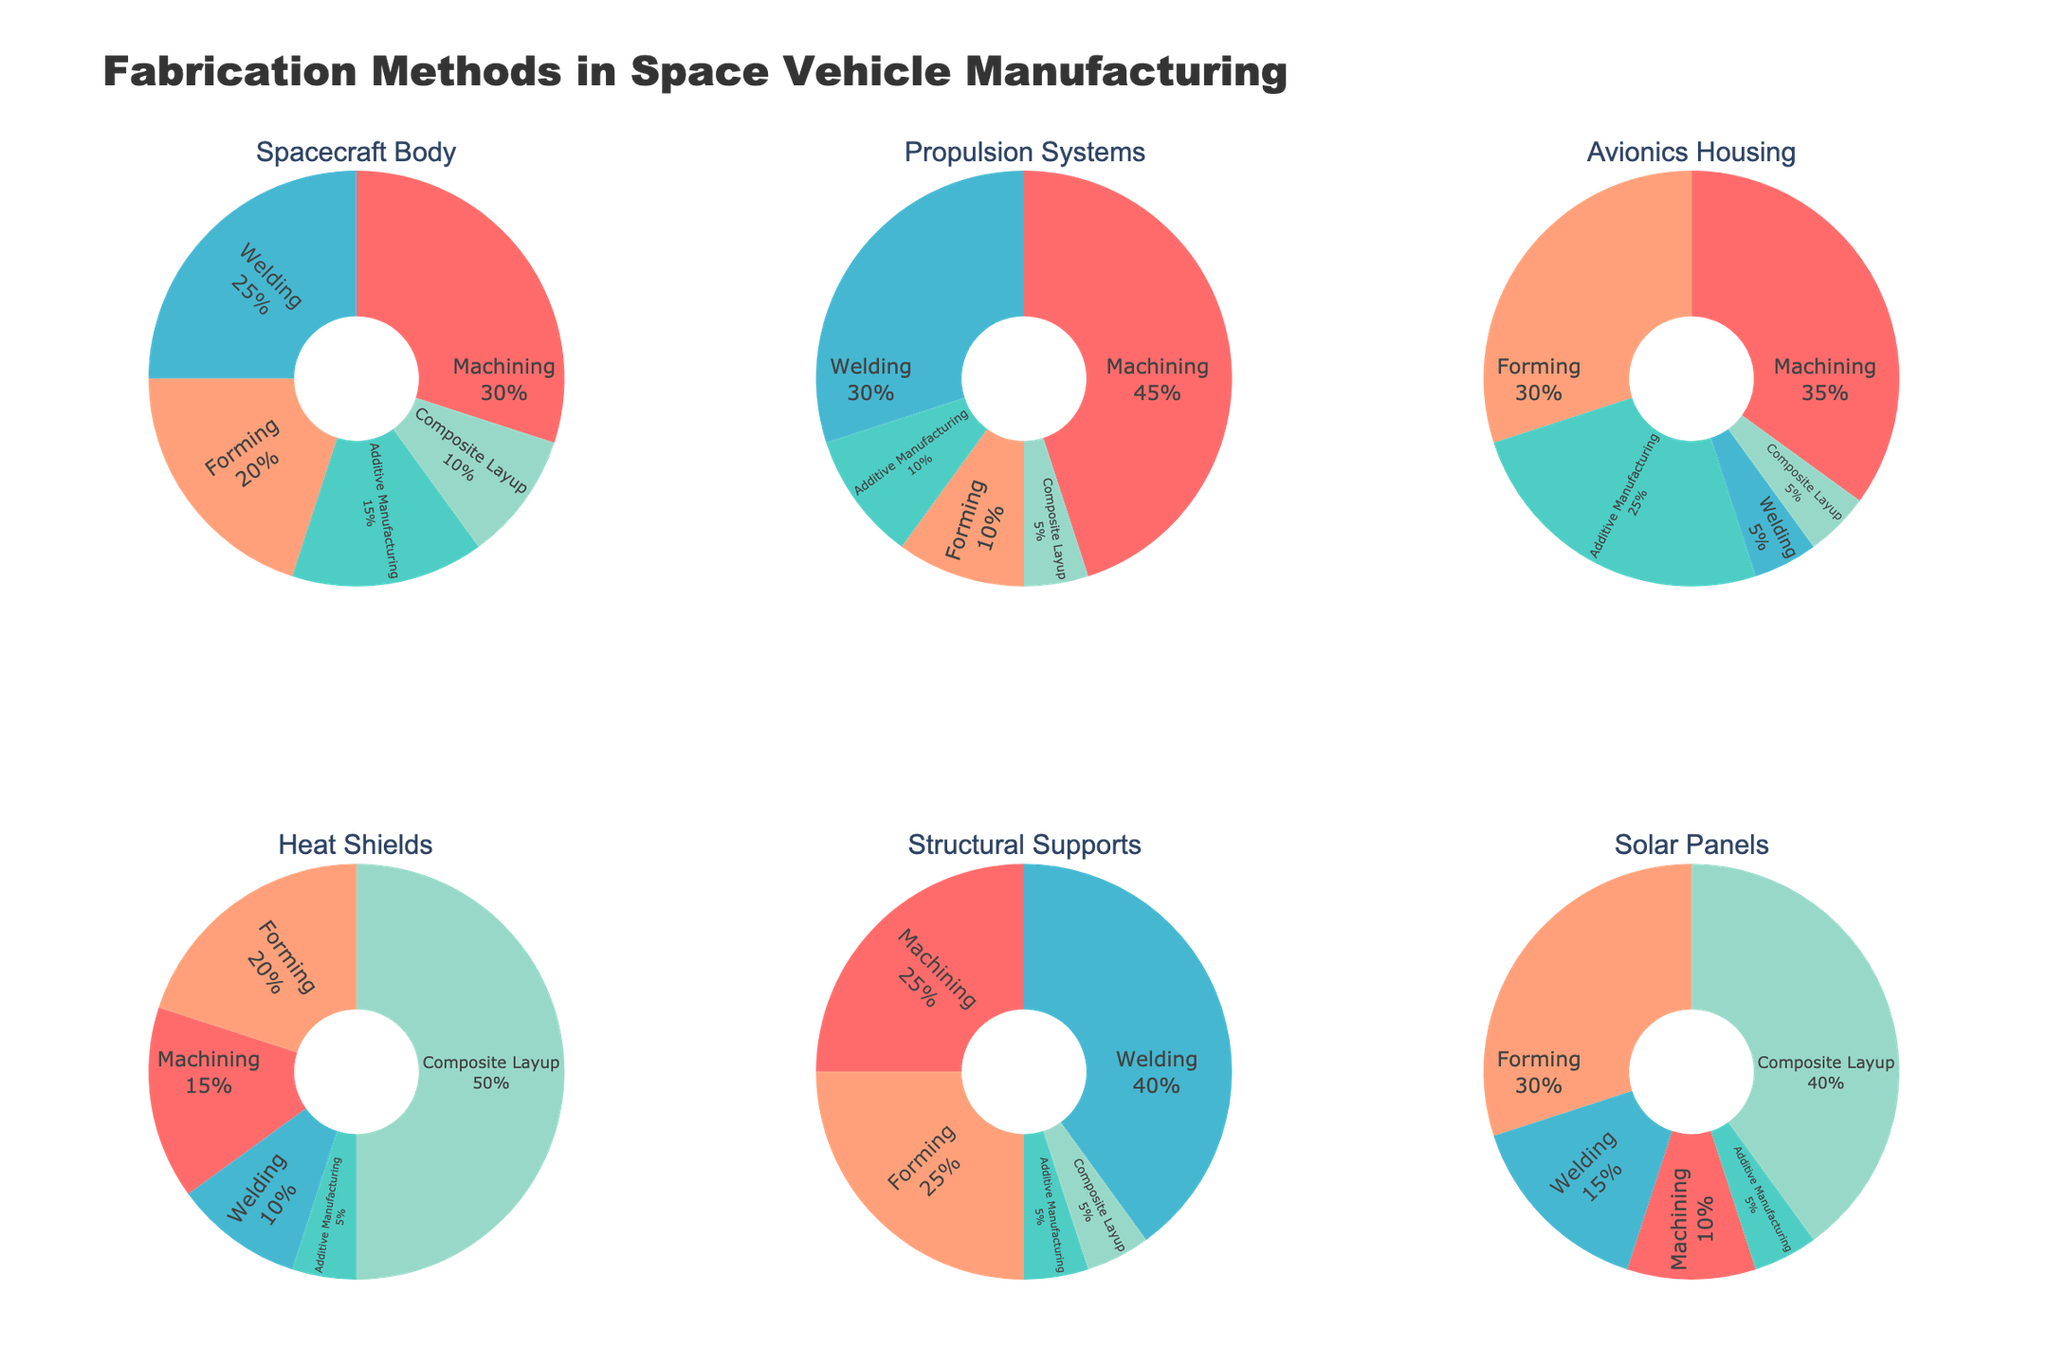What is the title of the figure? The title is located at the top of the figure and it provides a summary of the overall content of the chart. It reads "Fabrication Methods in Space Vehicle Manufacturing".
Answer: Fabrication Methods in Space Vehicle Manufacturing Which fabrication method is used the most for solar panels? By looking at the pie chart for solar panels, you can see that the largest segment is colored differently and labeled. This segment represents 'Composite Layup'.
Answer: Composite Layup What percentage of welding is used in structural supports? In the pie chart for structural supports, the segment labeled 'Welding' shows the percentage usage, which is 40%.
Answer: 40% Which category has the highest use of machining? Reviewing all the pie charts, the propulsion systems pie chart shows the highest percentage use of machining, which is 45%.
Answer: Propulsion Systems How do the percentages of additive manufacturing in avionics housing compare with heat shields? Look at the segments labeled 'Additive Manufacturing' in the avionics housing and heat shields pie charts. Avionics housing has 25% while heat shields have 5%. Additionally, 25% is greater than 5%.
Answer: Avionics housing has 25% whereas Heat Shields has 5% What is the sum of percentages for forming and composite layup in the spacecraft body chart? In the spacecraft body chart, forming is 20% and composite layup is 10%. Adding them together, the sum is 30%.
Answer: 30% What aspect specifically distinguishes the heat shields from the other categories? In the pie chart for heat shields, the percentage for composite layup is noticeably high at 50%, which distinguishes it from the other categories that have much lower values for composite layup.
Answer: High percentage (50%) of Composite Layup Between spacecraft body and propulsion systems, which one has a higher percentage dedicated to welding? By comparing the welding segments, the spacecraft body has 25% and propulsion systems have 30%. Thus, propulsion systems have a higher percentage dedicated to welding.
Answer: Propulsion Systems In which category does forming make up the largest part of the fabrication methods? By checking the forming segments across all pie charts, the largest segment for forming is found in the solar panels category, which is 30%.
Answer: Solar Panels If you combine the percentages of welding for spacecraft body and structural supports, what is the total? The welding percentage for spacecraft body is 25% and for structural supports is 40%. Adding them gives a total of 65%.
Answer: 65% 